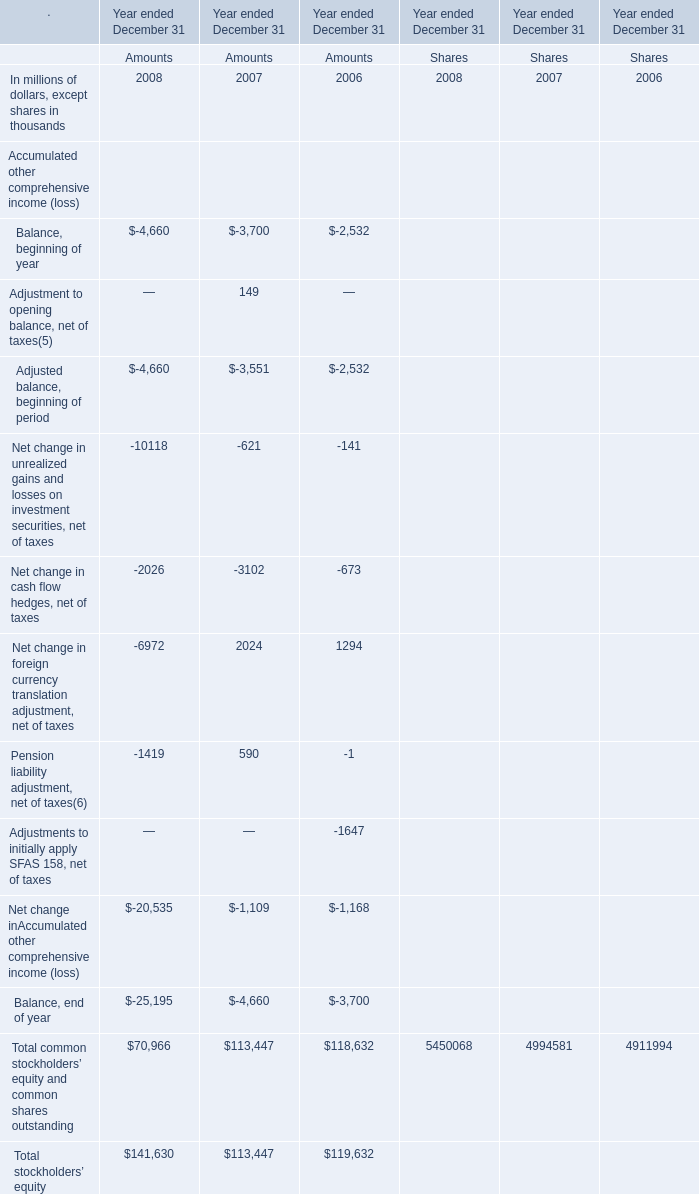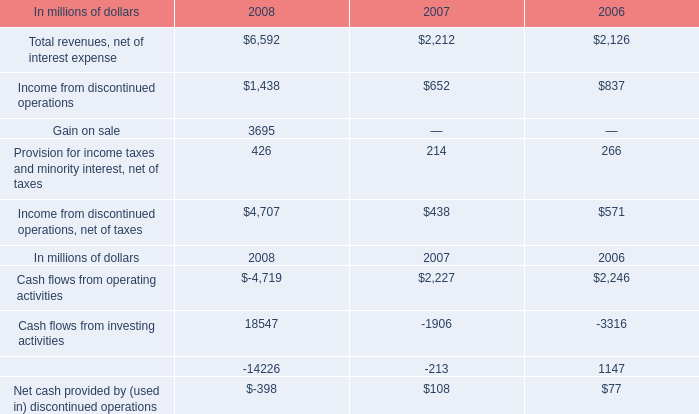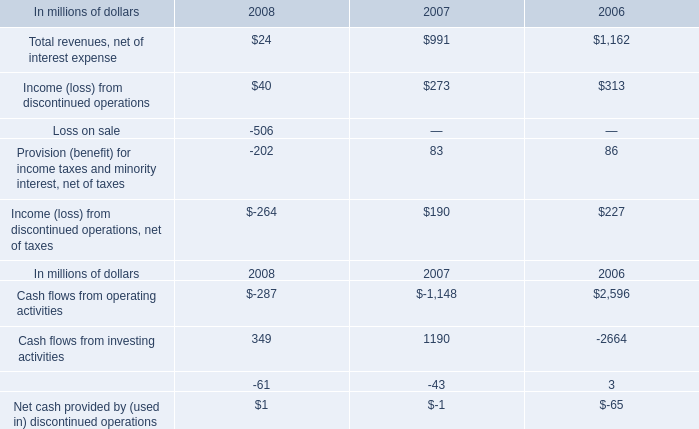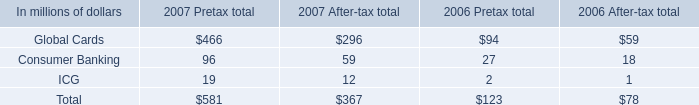What's the growth rate of Total common stockholders' equity and common shares outstanding in 2008? 
Computations: ((70966 - 113447) / 113447)
Answer: -0.37446. 